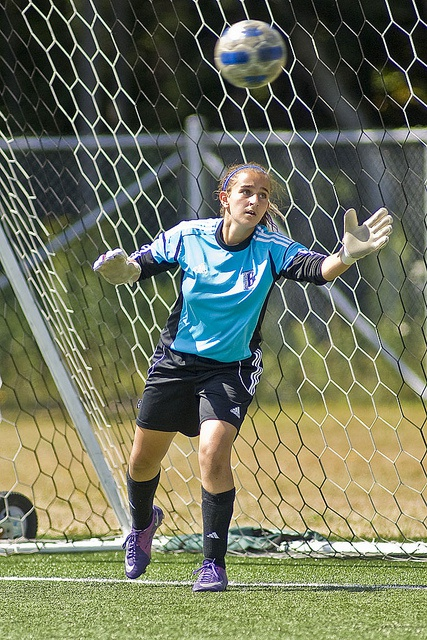Describe the objects in this image and their specific colors. I can see people in black, white, gray, and teal tones and sports ball in black, gray, darkgray, white, and navy tones in this image. 